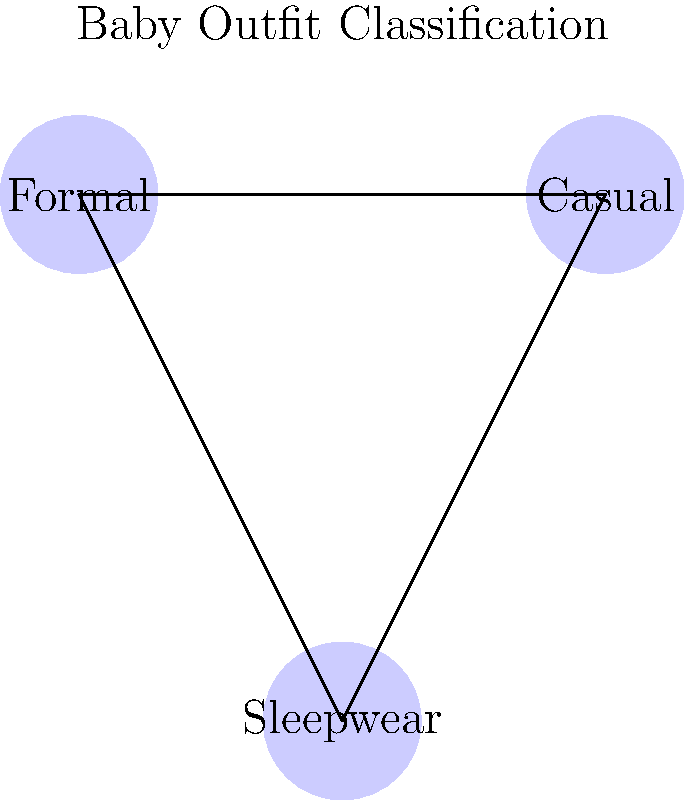In a machine learning model for classifying baby outfits, which feature would be most important for distinguishing between formal and casual categories? To distinguish between formal and casual baby outfits, we need to consider several key features:

1. Fabric type: Formal outfits often use more luxurious fabrics like silk or satin, while casual outfits use cotton or denim.

2. Color palette: Formal outfits typically use more subdued or classic colors, while casual outfits may have brighter or more playful colors.

3. Embellishments: Formal outfits might have more intricate details like lace, embroidery, or sequins.

4. Structure: Formal outfits tend to have a more structured appearance with crisp lines, while casual outfits are more relaxed.

5. Accessories: Formal outfits might include accessories like bow ties or fancy hair clips.

Among these features, the fabric type is often the most distinguishing factor between formal and casual baby outfits. The texture and appearance of the fabric can immediately signal whether an outfit is meant for a special occasion or everyday wear.

While color, embellishments, structure, and accessories are important, they can sometimes overlap between formal and casual categories. However, the fabric type is consistently different between the two categories, making it the most reliable feature for classification.
Answer: Fabric type 